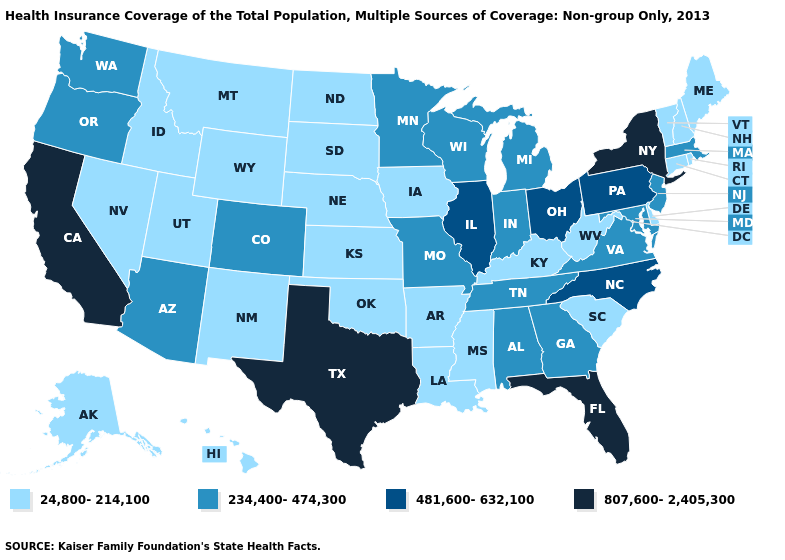Among the states that border Oregon , does Nevada have the lowest value?
Keep it brief. Yes. How many symbols are there in the legend?
Be succinct. 4. Is the legend a continuous bar?
Short answer required. No. What is the value of Rhode Island?
Give a very brief answer. 24,800-214,100. Among the states that border Colorado , does Wyoming have the lowest value?
Concise answer only. Yes. Name the states that have a value in the range 481,600-632,100?
Concise answer only. Illinois, North Carolina, Ohio, Pennsylvania. What is the highest value in states that border Maryland?
Write a very short answer. 481,600-632,100. What is the value of Mississippi?
Keep it brief. 24,800-214,100. Does Colorado have a lower value than Pennsylvania?
Keep it brief. Yes. What is the lowest value in the MidWest?
Answer briefly. 24,800-214,100. What is the value of Idaho?
Be succinct. 24,800-214,100. Does Kentucky have the same value as Alabama?
Short answer required. No. Does the first symbol in the legend represent the smallest category?
Write a very short answer. Yes. Among the states that border Wyoming , does Colorado have the lowest value?
Keep it brief. No. What is the lowest value in the USA?
Write a very short answer. 24,800-214,100. 